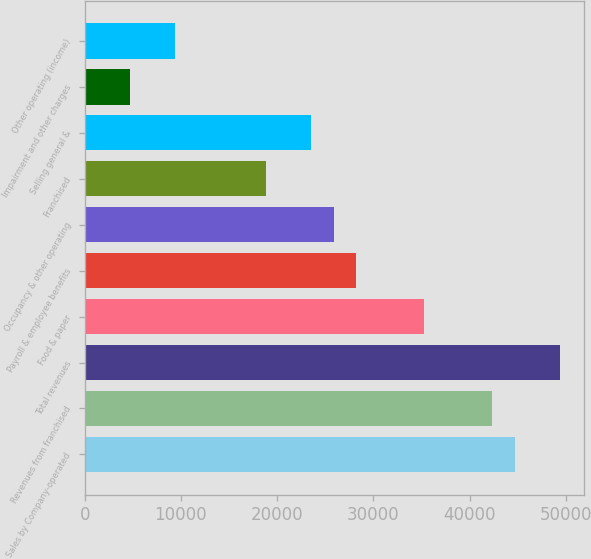Convert chart to OTSL. <chart><loc_0><loc_0><loc_500><loc_500><bar_chart><fcel>Sales by Company-operated<fcel>Revenues from franchised<fcel>Total revenues<fcel>Food & paper<fcel>Payroll & employee benefits<fcel>Occupancy & other operating<fcel>Franchised<fcel>Selling general &<fcel>Impairment and other charges<fcel>Other operating (income)<nl><fcel>44691.1<fcel>42339.1<fcel>49395.3<fcel>35282.8<fcel>28226.6<fcel>25874.5<fcel>18818.3<fcel>23522.4<fcel>4705.78<fcel>9409.94<nl></chart> 